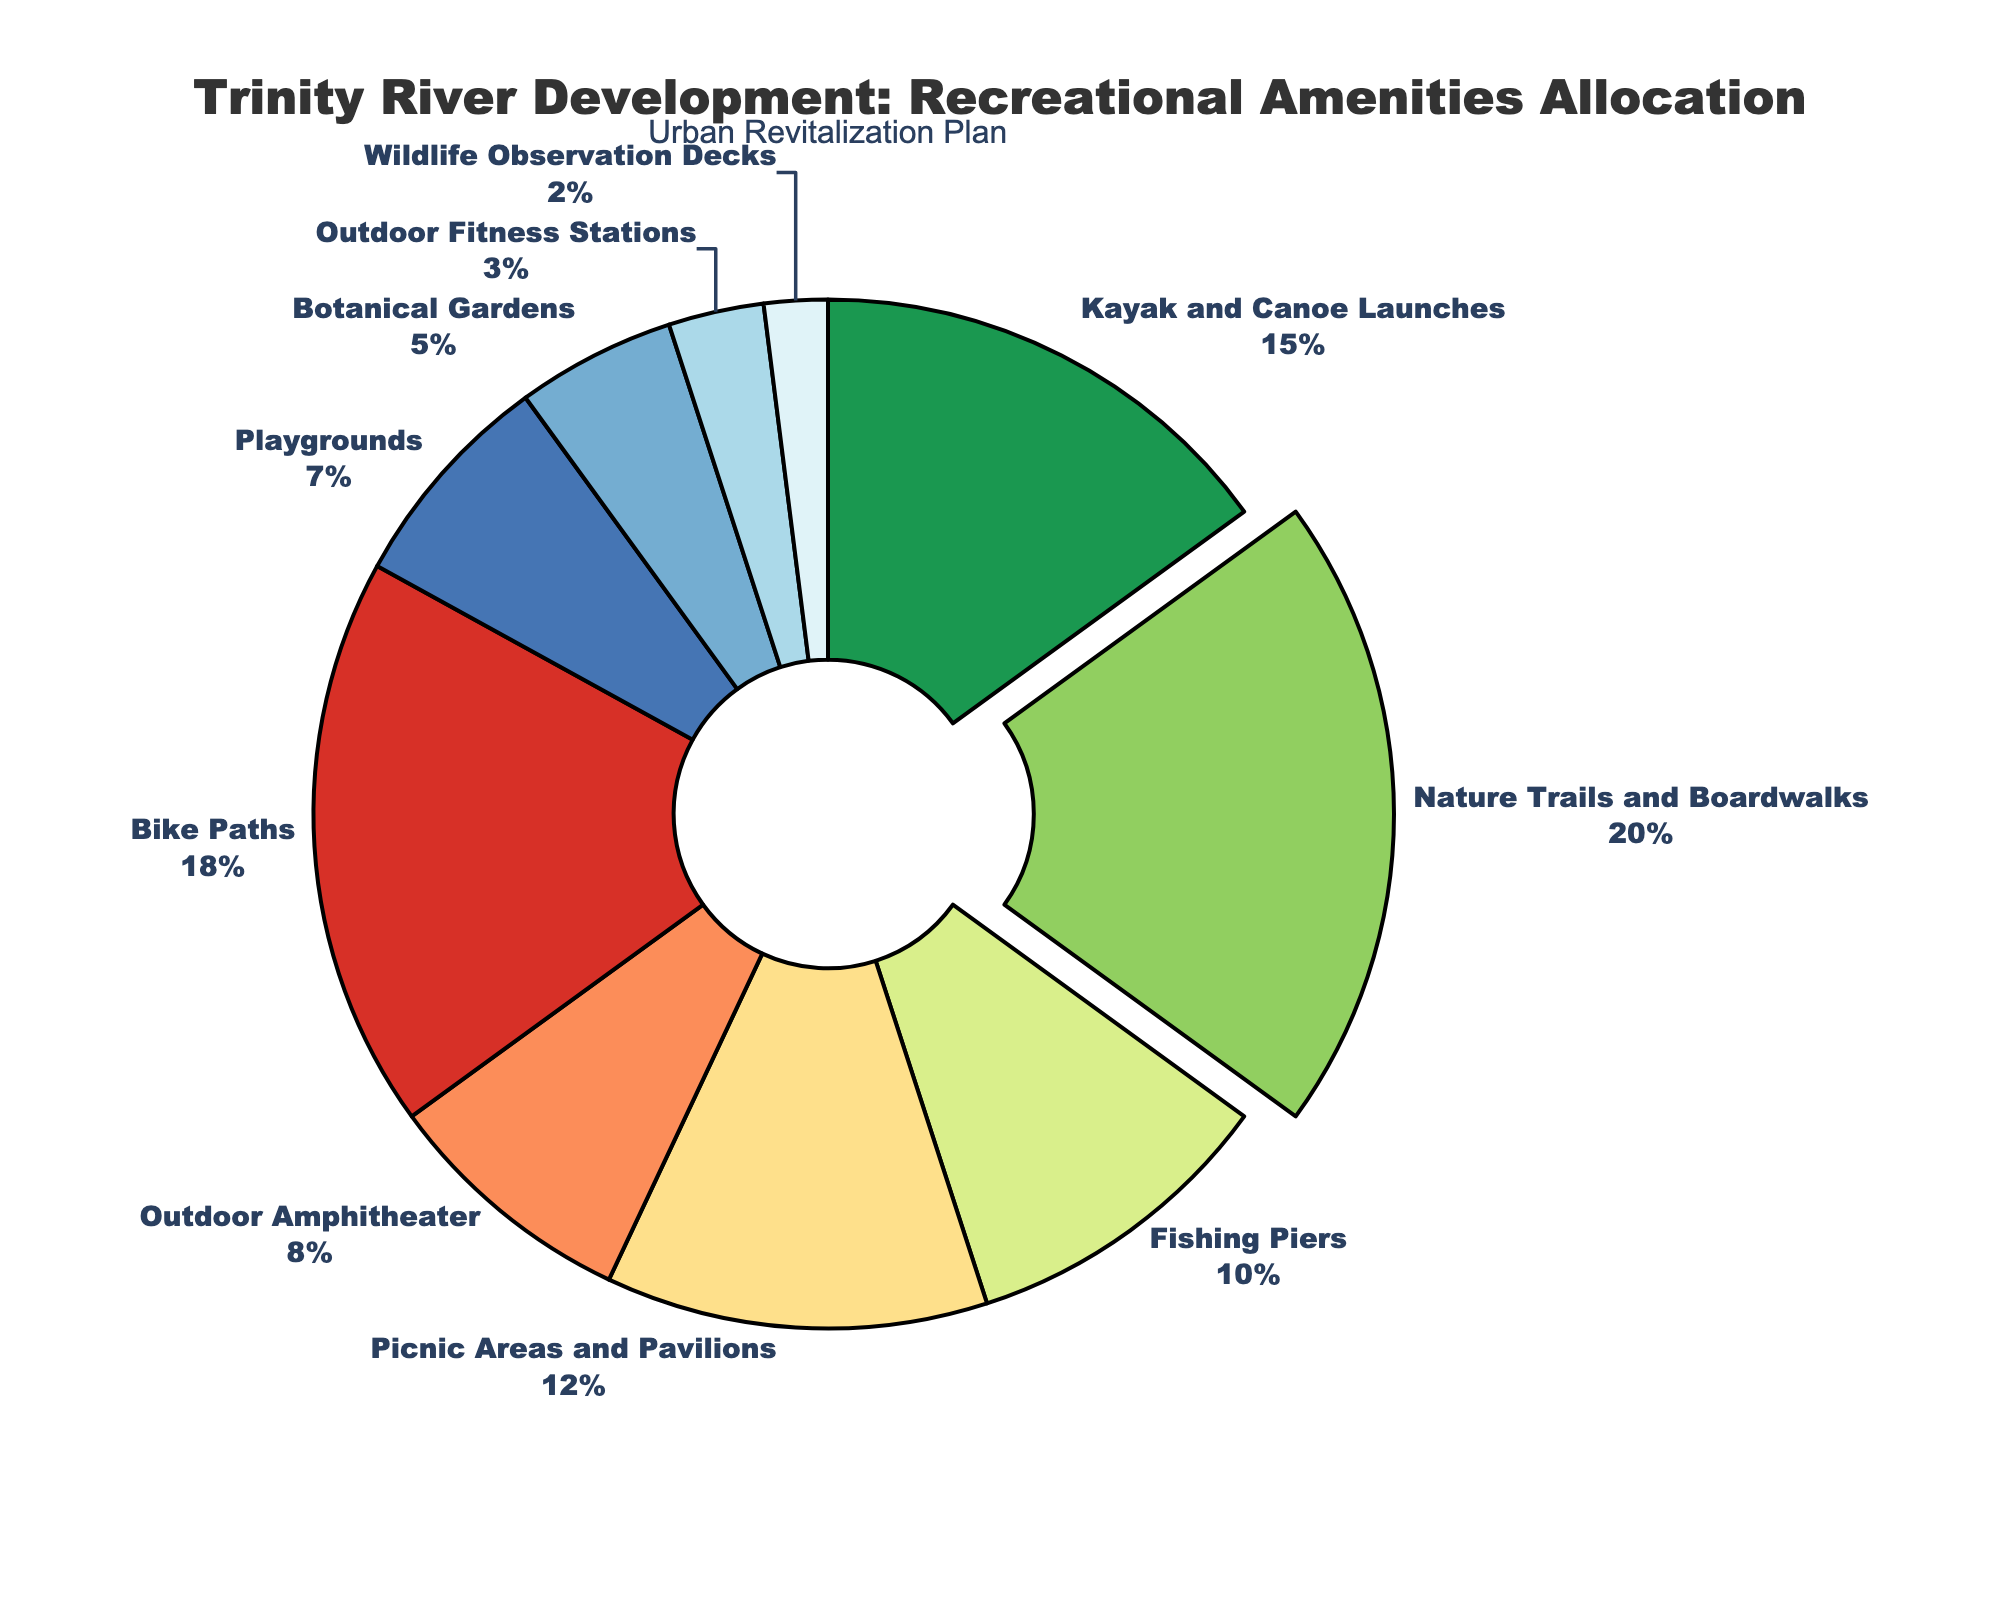What percentage of the total allocation is dedicated to Nature Trails and Boardwalks? Identify the segment labeled as 'Nature Trails and Boardwalks' on the pie chart and note the percentage allocated.
Answer: 20% Which amenity has the smallest allocation percentage? Locate the segment with the smallest portion on the chart, labeled as 'Wildlife Observation Decks', and note the allocation percentage.
Answer: Wildlife Observation Decks How does the allocation for Bike Paths compare to that for Kayak and Canoe Launches? Identify the segments for 'Bike Paths' and 'Kayak and Canoe Launches'. Compare their percentages and note that Bike Paths has 18% while Kayak and Canoe Launches has 15%.
Answer: Bike Paths has a higher allocation What is the total percentage allocated to both Picnic Areas and Pavilions and the Outdoor Amphitheater? Sum the percentages allocated to 'Picnic Areas and Pavilions' (12%) and 'Outdoor Amphitheater' (8%). This results in 12% + 8% = 20%.
Answer: 20% Which amenities have an allocation percentage greater than 10%? Identify all segments where the percentage is greater than 10%. These are 'Kayak and Canoe Launches' (15%), 'Nature Trails and Boardwalks' (20%), 'Bike Paths' (18%), and 'Picnic Areas and Pavilions' (12%).
Answer: Kayak and Canoe Launches, Nature Trails and Boardwalks, Bike Paths, Picnic Areas and Pavilions How many amenities have an allocation of 5% or less? Count the segments with allocations of 5% or less, which include 'Botanical Gardens' (5%), 'Outdoor Fitness Stations' (3%), and 'Wildlife Observation Decks' (2%). There are 3 such amenities.
Answer: 3 What is the combined allocation percentage for Outdoor Fitness Stations and Playgrounds? Sum the percentages for 'Outdoor Fitness Stations' (3%) and 'Playgrounds' (7%). This gives 3% + 7% = 10%.
Answer: 10% Among the amenities with the smallest allocations, which one has a slightly larger portion than Wildlife Observation Decks? Compare the segments with small allocations, noting that 'Outdoor Fitness Stations' (3%) has a slightly larger allocation than 'Wildlife Observation Decks' (2%).
Answer: Outdoor Fitness Stations What is the percentage difference between the largest and smallest allocations? Find the difference between the largest allocation ('Nature Trails and Boardwalks' at 20%) and the smallest allocation ('Wildlife Observation Decks' at 2%). The difference is 20% - 2% = 18%.
Answer: 18% Which segment is visually emphasized in the pie chart, and why might this be done? The visually emphasized segment is 'Nature Trails and Boardwalks' because it has the largest allocation percentage (20%), making it a key feature in the development project. This emphasis indicates its significance in the overall plan.
Answer: Nature Trails and Boardwalks 